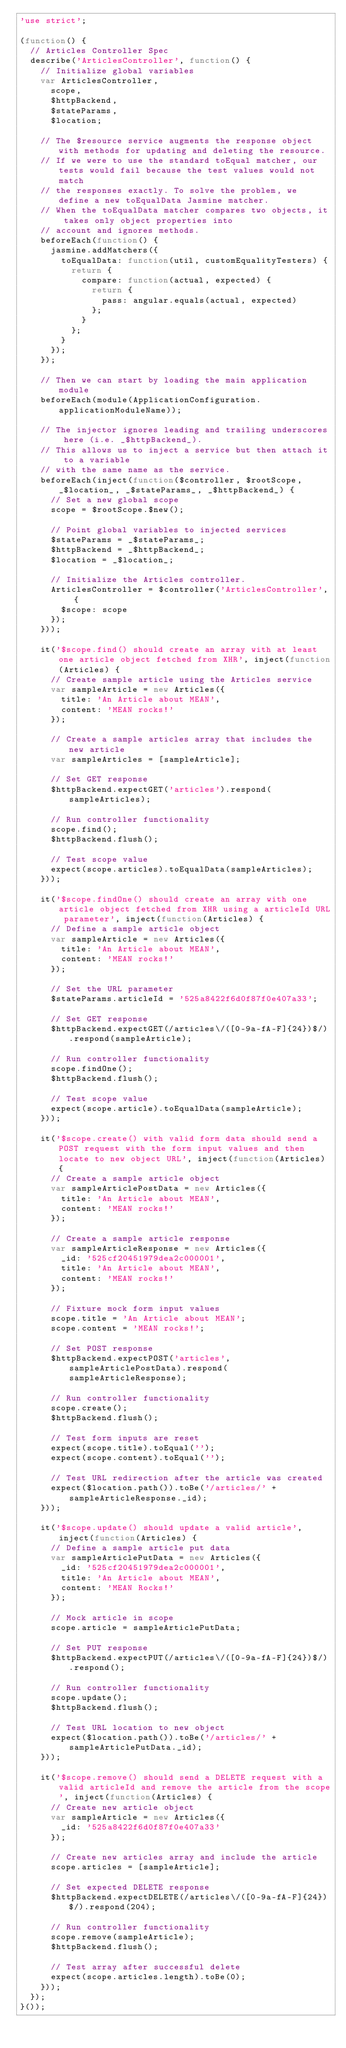<code> <loc_0><loc_0><loc_500><loc_500><_JavaScript_>'use strict';

(function() {
	// Articles Controller Spec
	describe('ArticlesController', function() {
		// Initialize global variables
		var ArticlesController,
			scope,
			$httpBackend,
			$stateParams,
			$location;

		// The $resource service augments the response object with methods for updating and deleting the resource.
		// If we were to use the standard toEqual matcher, our tests would fail because the test values would not match
		// the responses exactly. To solve the problem, we define a new toEqualData Jasmine matcher.
		// When the toEqualData matcher compares two objects, it takes only object properties into
		// account and ignores methods.
		beforeEach(function() {
			jasmine.addMatchers({
				toEqualData: function(util, customEqualityTesters) {
					return {
						compare: function(actual, expected) {
							return {
								pass: angular.equals(actual, expected)
							};
						}
					};
				}
			});
		});

		// Then we can start by loading the main application module
		beforeEach(module(ApplicationConfiguration.applicationModuleName));

		// The injector ignores leading and trailing underscores here (i.e. _$httpBackend_).
		// This allows us to inject a service but then attach it to a variable
		// with the same name as the service.
		beforeEach(inject(function($controller, $rootScope, _$location_, _$stateParams_, _$httpBackend_) {
			// Set a new global scope
			scope = $rootScope.$new();

			// Point global variables to injected services
			$stateParams = _$stateParams_;
			$httpBackend = _$httpBackend_;
			$location = _$location_;

			// Initialize the Articles controller.
			ArticlesController = $controller('ArticlesController', {
				$scope: scope
			});
		}));

		it('$scope.find() should create an array with at least one article object fetched from XHR', inject(function(Articles) {
			// Create sample article using the Articles service
			var sampleArticle = new Articles({
				title: 'An Article about MEAN',
				content: 'MEAN rocks!'
			});

			// Create a sample articles array that includes the new article
			var sampleArticles = [sampleArticle];

			// Set GET response
			$httpBackend.expectGET('articles').respond(sampleArticles);

			// Run controller functionality
			scope.find();
			$httpBackend.flush();

			// Test scope value
			expect(scope.articles).toEqualData(sampleArticles);
		}));

		it('$scope.findOne() should create an array with one article object fetched from XHR using a articleId URL parameter', inject(function(Articles) {
			// Define a sample article object
			var sampleArticle = new Articles({
				title: 'An Article about MEAN',
				content: 'MEAN rocks!'
			});

			// Set the URL parameter
			$stateParams.articleId = '525a8422f6d0f87f0e407a33';

			// Set GET response
			$httpBackend.expectGET(/articles\/([0-9a-fA-F]{24})$/).respond(sampleArticle);

			// Run controller functionality
			scope.findOne();
			$httpBackend.flush();

			// Test scope value
			expect(scope.article).toEqualData(sampleArticle);
		}));

		it('$scope.create() with valid form data should send a POST request with the form input values and then locate to new object URL', inject(function(Articles) {
			// Create a sample article object
			var sampleArticlePostData = new Articles({
				title: 'An Article about MEAN',
				content: 'MEAN rocks!'
			});

			// Create a sample article response
			var sampleArticleResponse = new Articles({
				_id: '525cf20451979dea2c000001',
				title: 'An Article about MEAN',
				content: 'MEAN rocks!'
			});

			// Fixture mock form input values
			scope.title = 'An Article about MEAN';
			scope.content = 'MEAN rocks!';

			// Set POST response
			$httpBackend.expectPOST('articles', sampleArticlePostData).respond(sampleArticleResponse);

			// Run controller functionality
			scope.create();
			$httpBackend.flush();

			// Test form inputs are reset
			expect(scope.title).toEqual('');
			expect(scope.content).toEqual('');

			// Test URL redirection after the article was created
			expect($location.path()).toBe('/articles/' + sampleArticleResponse._id);
		}));

		it('$scope.update() should update a valid article', inject(function(Articles) {
			// Define a sample article put data
			var sampleArticlePutData = new Articles({
				_id: '525cf20451979dea2c000001',
				title: 'An Article about MEAN',
				content: 'MEAN Rocks!'
			});

			// Mock article in scope
			scope.article = sampleArticlePutData;

			// Set PUT response
			$httpBackend.expectPUT(/articles\/([0-9a-fA-F]{24})$/).respond();

			// Run controller functionality
			scope.update();
			$httpBackend.flush();

			// Test URL location to new object
			expect($location.path()).toBe('/articles/' + sampleArticlePutData._id);
		}));

		it('$scope.remove() should send a DELETE request with a valid articleId and remove the article from the scope', inject(function(Articles) {
			// Create new article object
			var sampleArticle = new Articles({
				_id: '525a8422f6d0f87f0e407a33'
			});

			// Create new articles array and include the article
			scope.articles = [sampleArticle];

			// Set expected DELETE response
			$httpBackend.expectDELETE(/articles\/([0-9a-fA-F]{24})$/).respond(204);

			// Run controller functionality
			scope.remove(sampleArticle);
			$httpBackend.flush();

			// Test array after successful delete
			expect(scope.articles.length).toBe(0);
		}));
	});
}());</code> 